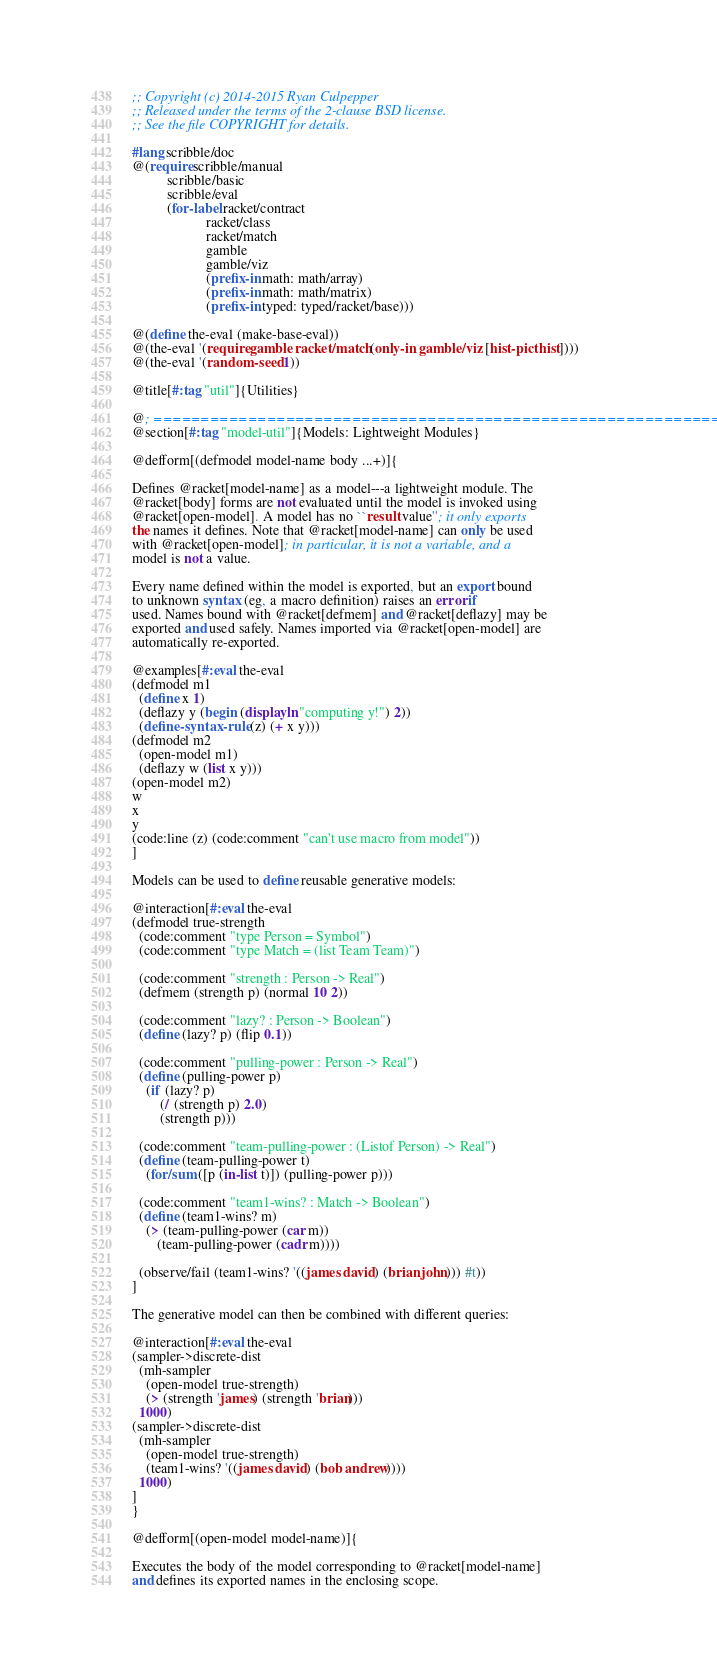<code> <loc_0><loc_0><loc_500><loc_500><_Racket_>;; Copyright (c) 2014-2015 Ryan Culpepper
;; Released under the terms of the 2-clause BSD license.
;; See the file COPYRIGHT for details.

#lang scribble/doc
@(require scribble/manual
          scribble/basic
          scribble/eval
          (for-label racket/contract
                     racket/class
                     racket/match
                     gamble
                     gamble/viz
                     (prefix-in math: math/array)
                     (prefix-in math: math/matrix)
                     (prefix-in typed: typed/racket/base)))

@(define the-eval (make-base-eval))
@(the-eval '(require gamble racket/match (only-in gamble/viz [hist-pict hist])))
@(the-eval '(random-seed 1))

@title[#:tag "util"]{Utilities}

@; ============================================================
@section[#:tag "model-util"]{Models: Lightweight Modules}

@defform[(defmodel model-name body ...+)]{

Defines @racket[model-name] as a model---a lightweight module. The
@racket[body] forms are not evaluated until the model is invoked using
@racket[open-model]. A model has no ``result value''; it only exports
the names it defines. Note that @racket[model-name] can only be used
with @racket[open-model]; in particular, it is not a variable, and a
model is not a value.

Every name defined within the model is exported, but an export bound
to unknown syntax (eg, a macro definition) raises an error if
used. Names bound with @racket[defmem] and @racket[deflazy] may be
exported and used safely. Names imported via @racket[open-model] are
automatically re-exported.

@examples[#:eval the-eval
(defmodel m1
  (define x 1)
  (deflazy y (begin (displayln "computing y!") 2))
  (define-syntax-rule (z) (+ x y)))
(defmodel m2
  (open-model m1)
  (deflazy w (list x y)))
(open-model m2)
w
x
y
(code:line (z) (code:comment "can't use macro from model"))
]

Models can be used to define reusable generative models:

@interaction[#:eval the-eval
(defmodel true-strength
  (code:comment "type Person = Symbol")
  (code:comment "type Match = (list Team Team)")

  (code:comment "strength : Person -> Real")
  (defmem (strength p) (normal 10 2))

  (code:comment "lazy? : Person -> Boolean")
  (define (lazy? p) (flip 0.1))

  (code:comment "pulling-power : Person -> Real")
  (define (pulling-power p)
    (if (lazy? p)
        (/ (strength p) 2.0)
        (strength p)))

  (code:comment "team-pulling-power : (Listof Person) -> Real")
  (define (team-pulling-power t)
    (for/sum ([p (in-list t)]) (pulling-power p)))

  (code:comment "team1-wins? : Match -> Boolean")
  (define (team1-wins? m)
    (> (team-pulling-power (car m))
       (team-pulling-power (cadr m))))

  (observe/fail (team1-wins? '((james david) (brian john))) #t))
]

The generative model can then be combined with different queries:

@interaction[#:eval the-eval
(sampler->discrete-dist
  (mh-sampler
    (open-model true-strength)
    (> (strength 'james) (strength 'brian)))
  1000)
(sampler->discrete-dist
  (mh-sampler
    (open-model true-strength)
    (team1-wins? '((james david) (bob andrew))))
  1000)
]
}

@defform[(open-model model-name)]{

Executes the body of the model corresponding to @racket[model-name]
and defines its exported names in the enclosing scope.</code> 